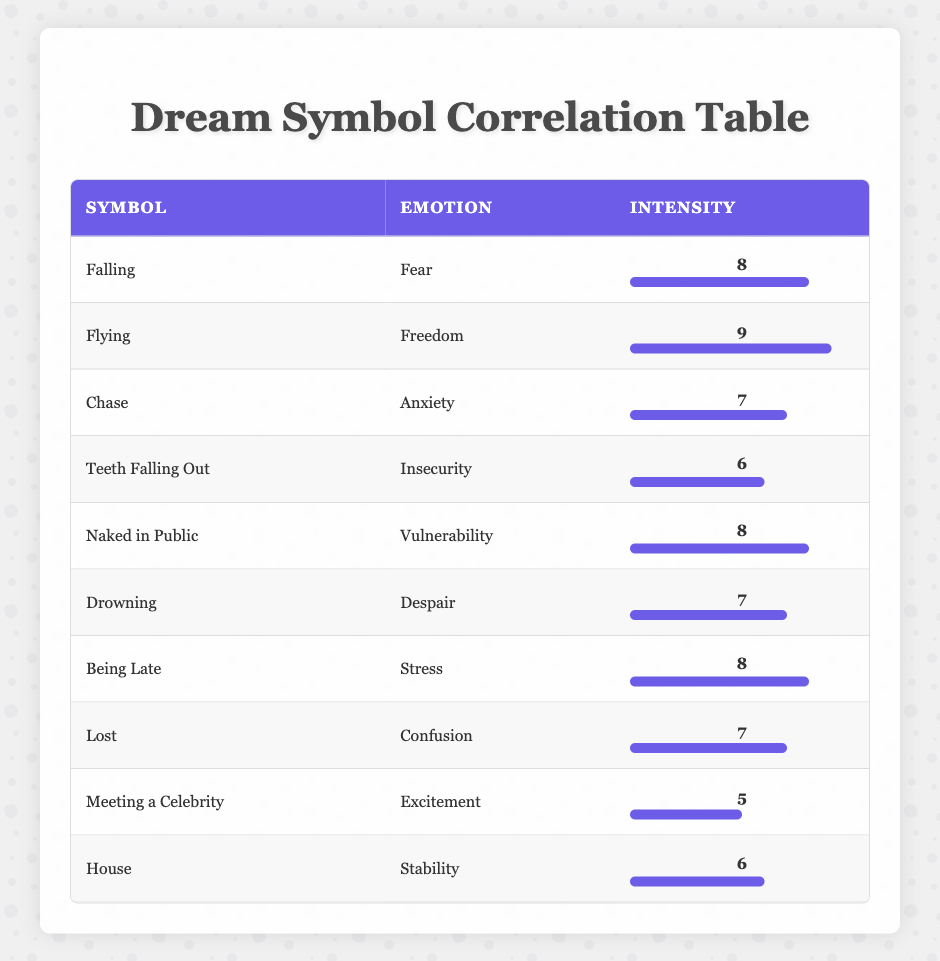What is the emotion associated with the dream symbol "Flying"? According to the table, the emotion associated with the dream symbol "Flying" is "Freedom".
Answer: Freedom What is the intensity level for the dream symbol "Chase"? The table shows that the intensity level for the dream symbol "Chase" is 7.
Answer: 7 Is the dream symbol "Teeth Falling Out" associated with a feeling of security? The table states that "Teeth Falling Out" is associated with "Insecurity," which means it is not related to a feeling of security.
Answer: No What is the average intensity of the emotions represented by the dream symbols associated with feelings of fear, stress, and anxiety? The dream symbols "Falling" (8), "Being Late" (8), and "Chase" (7) have intensity levels of 8, 8, and 7 respectively. The total intensity is 8 + 8 + 7 = 23. There are 3 symbols, so the average is 23 / 3 = 7.67.
Answer: 7.67 Which dream symbol has the highest intensity and what is the associated emotion? From the table, "Flying" has the highest intensity of 9, and the associated emotion is "Freedom."
Answer: Flying, Freedom What emotions are represented by the dream symbols that have an intensity greater than or equal to 8? The dream symbols with intensity greater than or equal to 8 are "Falling" (Fear), "Flying" (Freedom), "Naked in Public" (Vulnerability), and "Being Late" (Stress).
Answer: Fear, Freedom, Vulnerability, Stress How many dream symbols are associated with feelings of confusion or despair? The table lists "Lost" (Confusion), which is 1 symbol, and "Drowning" (Despair), which is another symbol, making a total of 2 symbols associated with those feelings.
Answer: 2 Is the intensity of the dream symbol "Meeting a Celebrity" greater than that of "House"? The intensity for "Meeting a Celebrity" is 5, while for "House" it is 6. Since 5 is less than 6, the statement is false.
Answer: No What is the difference in intensity between the dream symbols "Drowning" and "Chase"? The intensity for "Drowning" is 7 and for "Chase" it is also 7. The difference is then 7 - 7 = 0.
Answer: 0 